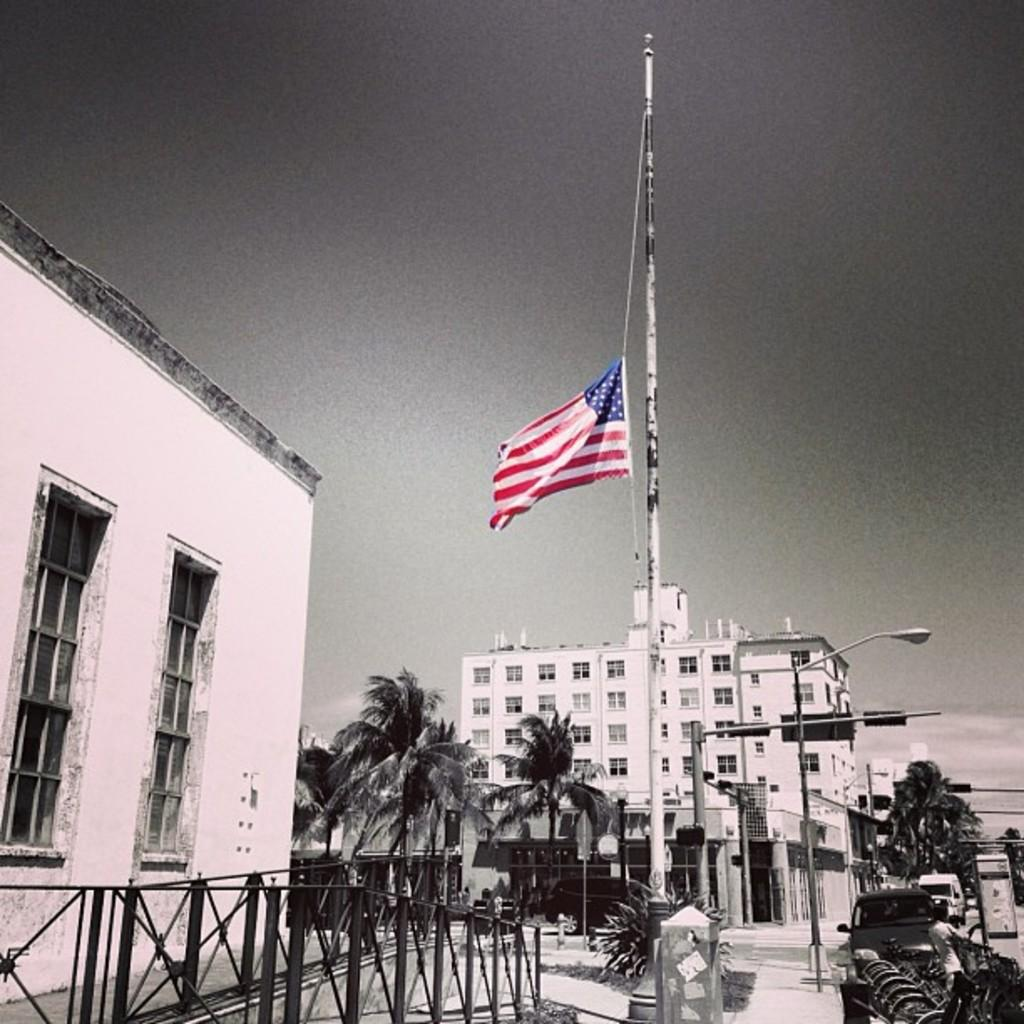What type of natural elements can be seen in the image? There are trees in the image. What man-made structures are present in the image? There are light poles and buildings in the image. What can be seen in the background of the image? There is a flag with white, red, and blue colors in the background of the image. What is the color of the sky in the image? The sky is visible in the image, and its color is described as gray. What type of machine is being used by the musicians in the image? There are no musicians or machines present in the image. What instrument is the artist playing in the image? There is no artist or instrument present in the image. 